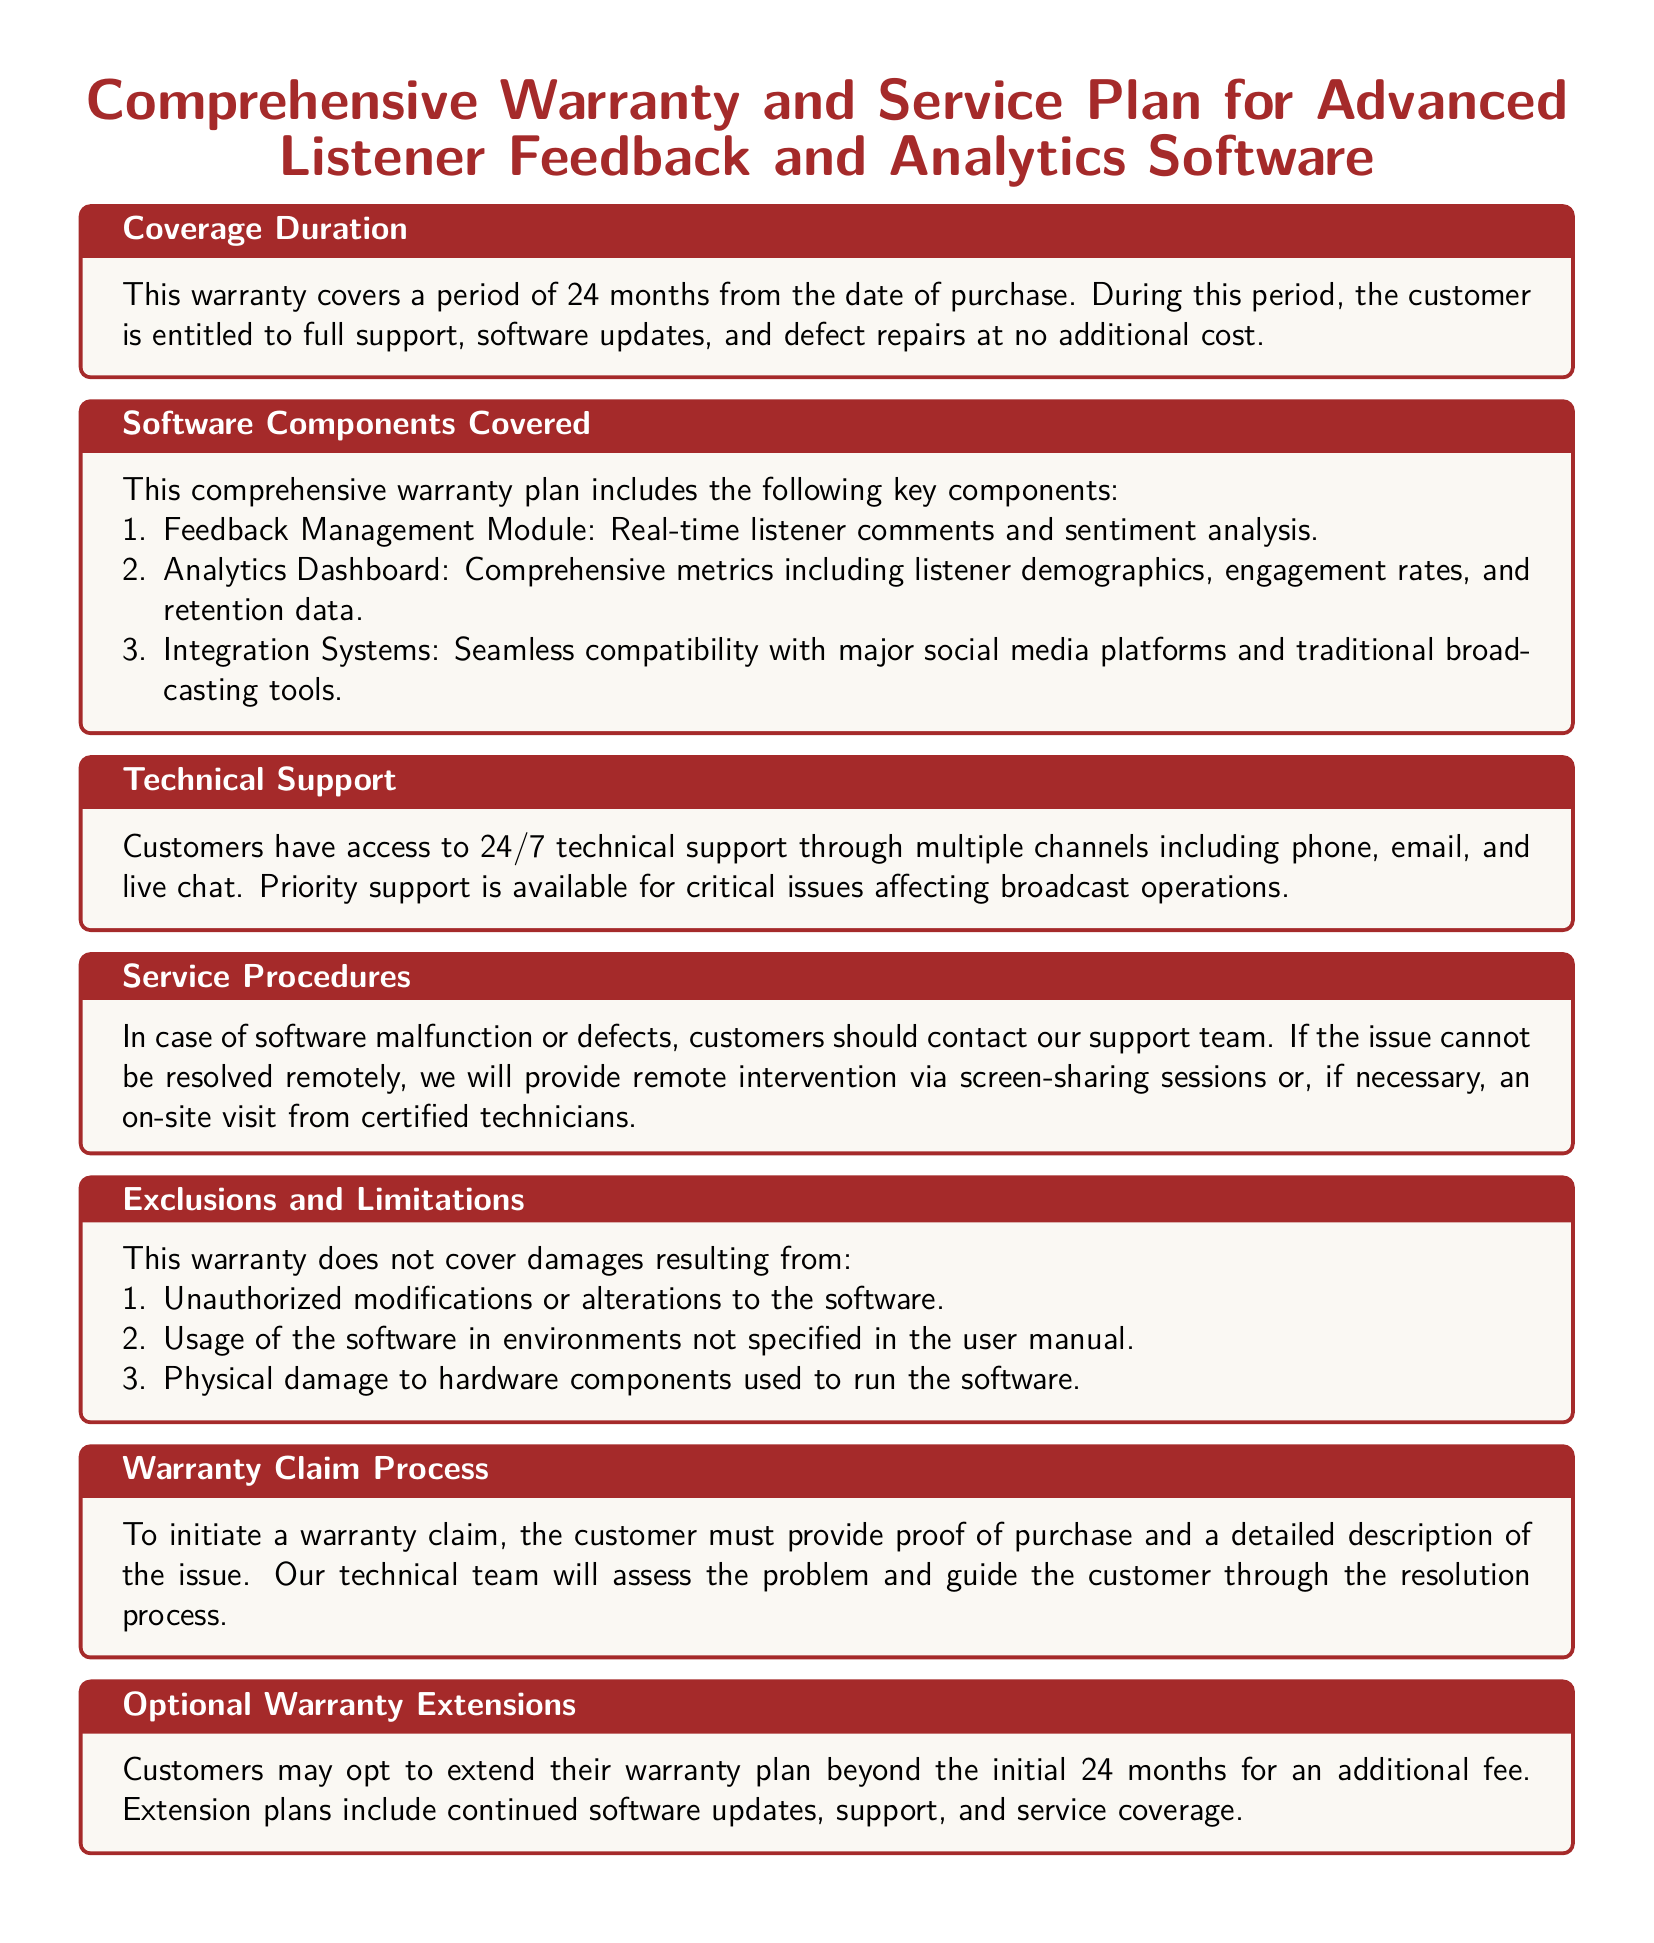What is the coverage duration of the warranty? The coverage duration is specified as a period of 24 months from the date of purchase.
Answer: 24 months What components are included in the warranty? The warranty covers specific software components including Feedback Management Module, Analytics Dashboard, and Integration Systems.
Answer: Feedback Management Module, Analytics Dashboard, Integration Systems What type of support is available? The document states that customers have access to 24/7 technical support through multiple channels.
Answer: 24/7 technical support What is the warranty claim process? To initiate a warranty claim, customers must provide proof of purchase and a detailed description of the issue.
Answer: Proof of purchase and issue description What are the exclusions listed in the warranty? The exclusions include damages from unauthorized modifications, improper usage, and physical damage to hardware components.
Answer: Unauthorized modifications, improper usage, physical damage What happens if an issue cannot be resolved remotely? If an issue cannot be resolved remotely, the warranty states that remote intervention or an on-site visit from certified technicians may occur.
Answer: Remote intervention or on-site visit What is the maximum duration for an optional warranty extension? While the document does not specify the maximum duration, it allows for extensions beyond the initial warranty period for an additional fee.
Answer: Not specified What is the priority support availability? The warranty mentions that priority support is available for critical issues affecting broadcast operations.
Answer: For critical issues 